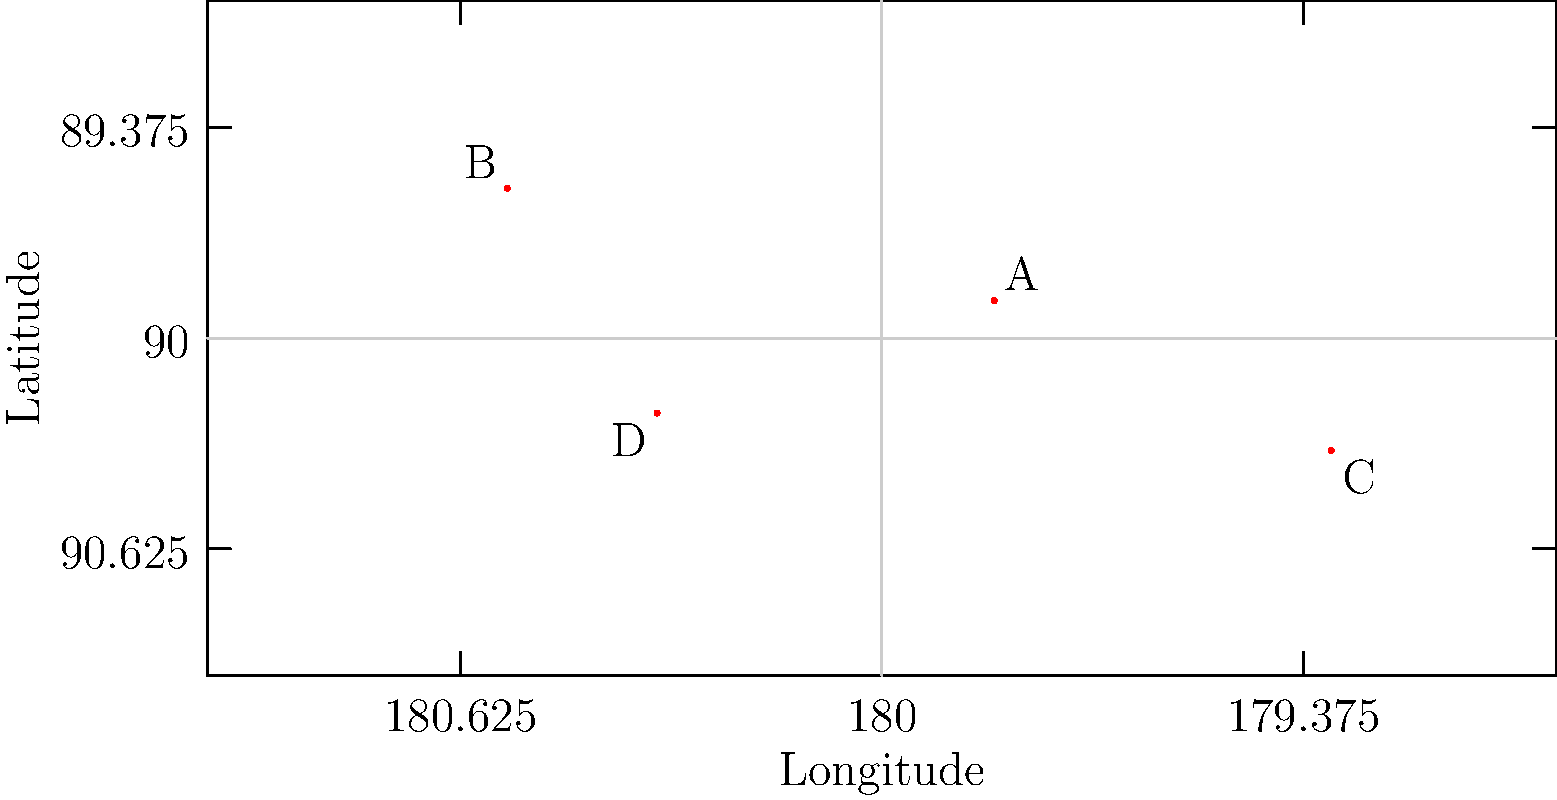As an experienced editor focused on human rights violations, you're tasked with identifying global hotspots for a new investigative report. The map above shows four locations (A, B, C, and D) where significant human rights violations have been reported. Which of these locations is closest to the coordinates (0°, 0°), also known as the intersection of the Prime Meridian and the Equator? To determine which location is closest to (0°, 0°), we need to:

1. Identify the approximate coordinates for each location:
   A: (30°E, 10°N)
   B: (100°W, 40°N)
   C: (120°E, 30°S)
   D: (60°W, 20°S)

2. Calculate the distance from each point to (0°, 0°) using the Pythagorean theorem. Although this isn't perfectly accurate for globe distances, it's a good approximation for this purpose.

3. The distance formula is: $d = \sqrt{(x-0)^2 + (y-0)^2}$, where x is longitude and y is latitude.

4. Calculate for each point:
   A: $d_A = \sqrt{30^2 + 10^2} = \sqrt{1000} \approx 31.6$
   B: $d_B = \sqrt{(-100)^2 + 40^2} = \sqrt{11600} \approx 107.7$
   C: $d_C = \sqrt{120^2 + (-30)^2} = \sqrt{15300} \approx 123.7$
   D: $d_D = \sqrt{(-60)^2 + (-20)^2} = \sqrt{4000} \approx 63.2$

5. Compare the distances. The smallest distance indicates the closest point to (0°, 0°).
Answer: A (30°E, 10°N) 